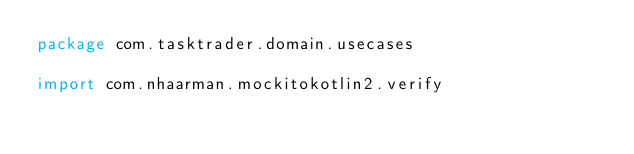<code> <loc_0><loc_0><loc_500><loc_500><_Kotlin_>package com.tasktrader.domain.usecases

import com.nhaarman.mockitokotlin2.verify</code> 